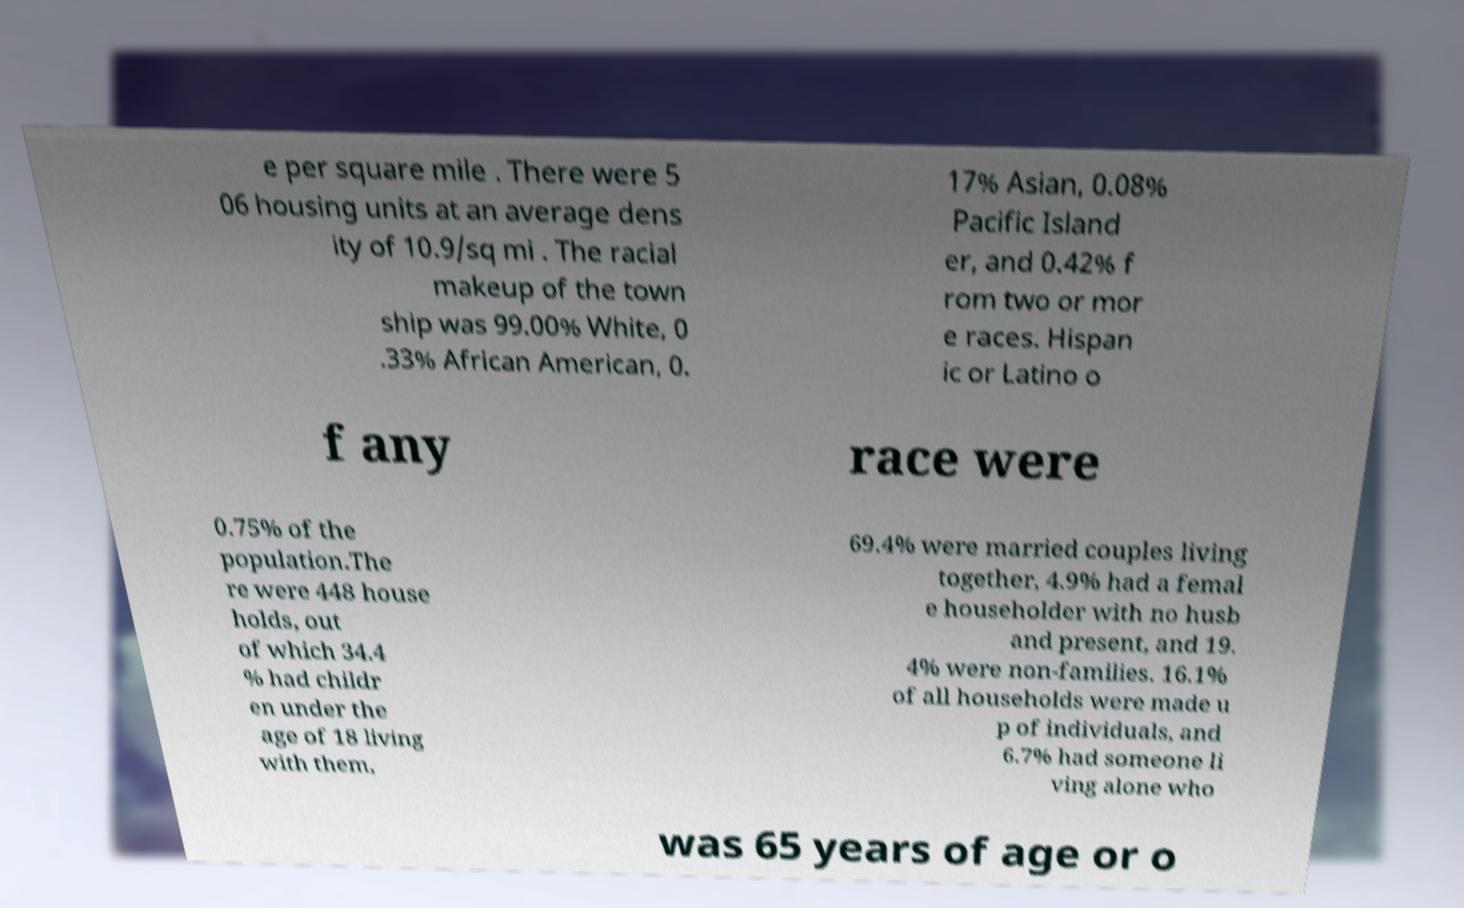I need the written content from this picture converted into text. Can you do that? e per square mile . There were 5 06 housing units at an average dens ity of 10.9/sq mi . The racial makeup of the town ship was 99.00% White, 0 .33% African American, 0. 17% Asian, 0.08% Pacific Island er, and 0.42% f rom two or mor e races. Hispan ic or Latino o f any race were 0.75% of the population.The re were 448 house holds, out of which 34.4 % had childr en under the age of 18 living with them, 69.4% were married couples living together, 4.9% had a femal e householder with no husb and present, and 19. 4% were non-families. 16.1% of all households were made u p of individuals, and 6.7% had someone li ving alone who was 65 years of age or o 